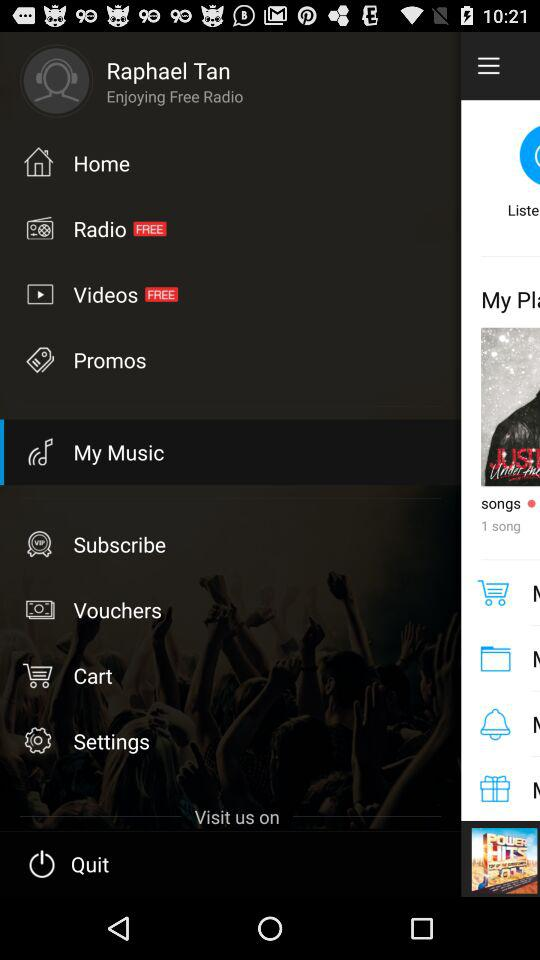What's the selected option? The selected option is "My Music". 